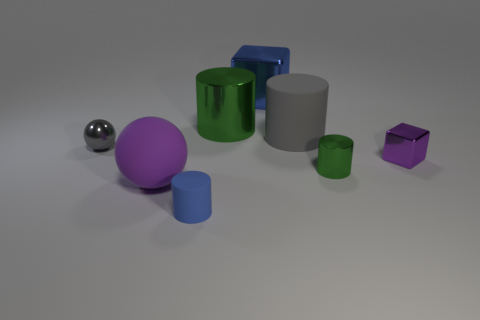Add 1 large purple cylinders. How many objects exist? 9 Subtract all large shiny cylinders. How many cylinders are left? 3 Subtract all green cylinders. How many cylinders are left? 2 Subtract all red spheres. How many yellow cylinders are left? 0 Subtract all tiny green cylinders. Subtract all purple rubber objects. How many objects are left? 6 Add 3 big purple matte things. How many big purple matte things are left? 4 Add 5 blue blocks. How many blue blocks exist? 6 Subtract 0 brown blocks. How many objects are left? 8 Subtract all cubes. How many objects are left? 6 Subtract 2 cylinders. How many cylinders are left? 2 